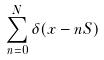<formula> <loc_0><loc_0><loc_500><loc_500>\sum _ { n = 0 } ^ { N } \delta ( x - n S )</formula> 